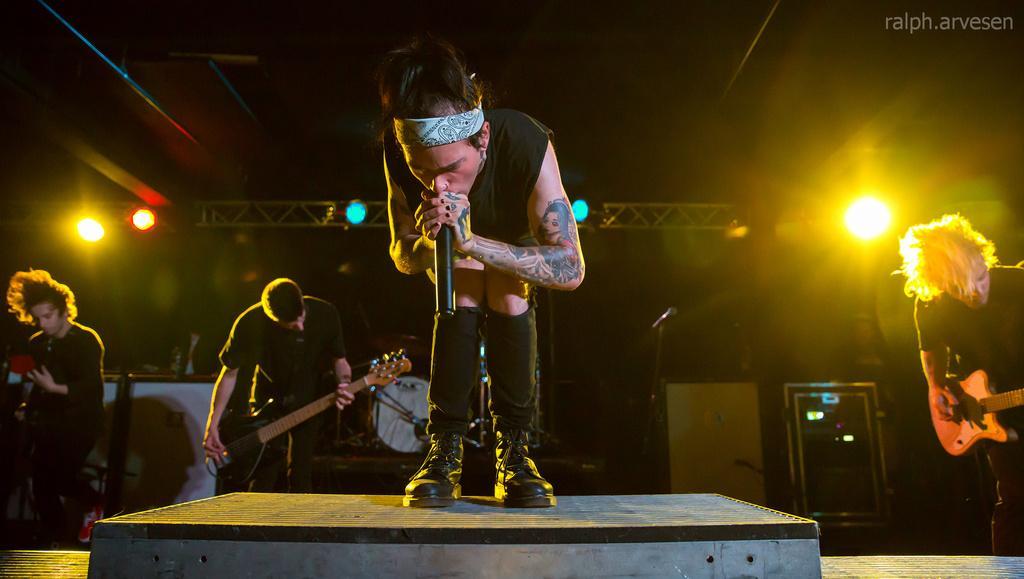Could you give a brief overview of what you see in this image? in the picture there are persons singing by catching a microphone and guitar. 